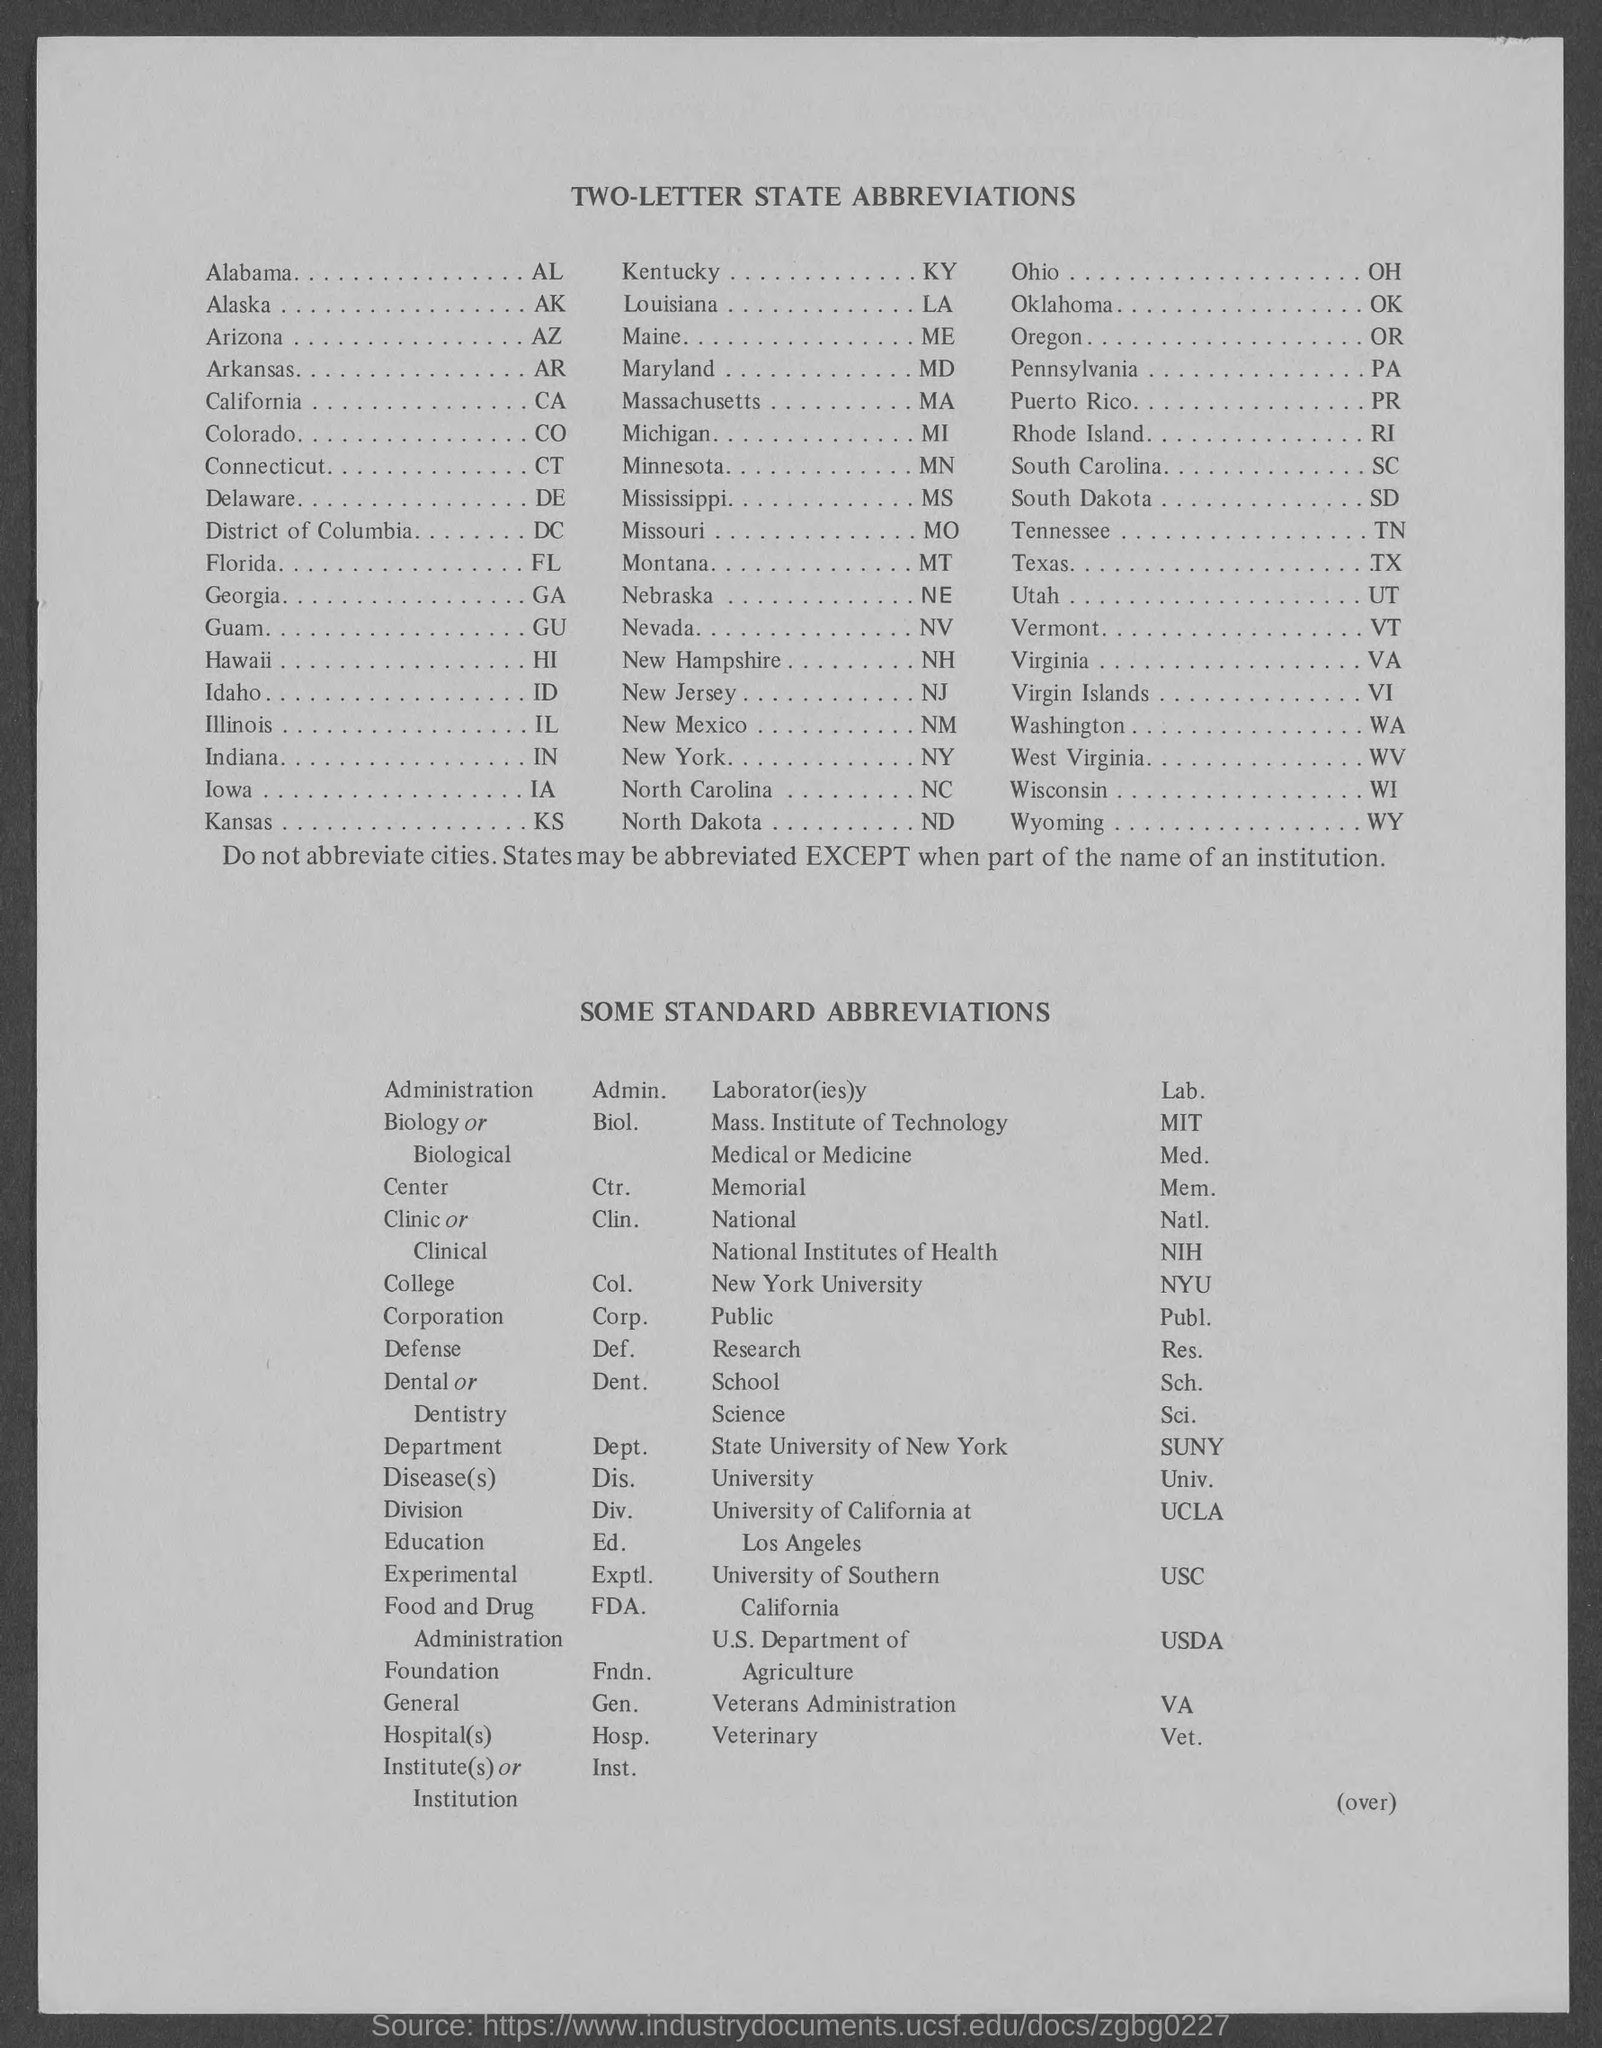Can you provide me with the abbreviation for California as seen in the image? Certainly! The abbreviation for California as shown in the image is 'CA'.  And what about the abbreviation for the National Institutes of Health? The abbreviation for the National Institutes of Health, according to the list in the image, is 'NIH'. 